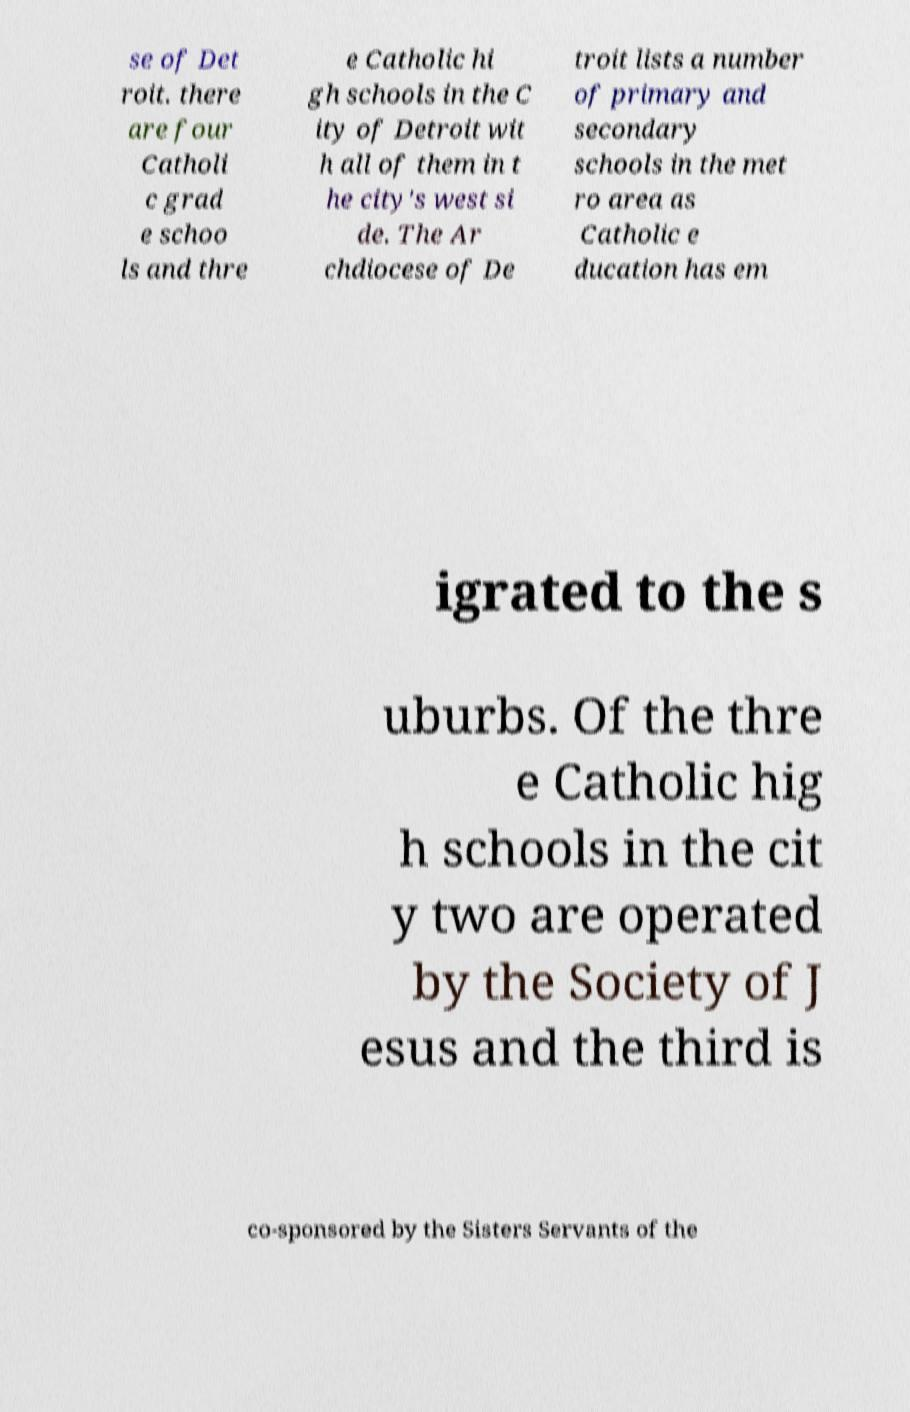For documentation purposes, I need the text within this image transcribed. Could you provide that? se of Det roit. there are four Catholi c grad e schoo ls and thre e Catholic hi gh schools in the C ity of Detroit wit h all of them in t he city's west si de. The Ar chdiocese of De troit lists a number of primary and secondary schools in the met ro area as Catholic e ducation has em igrated to the s uburbs. Of the thre e Catholic hig h schools in the cit y two are operated by the Society of J esus and the third is co-sponsored by the Sisters Servants of the 